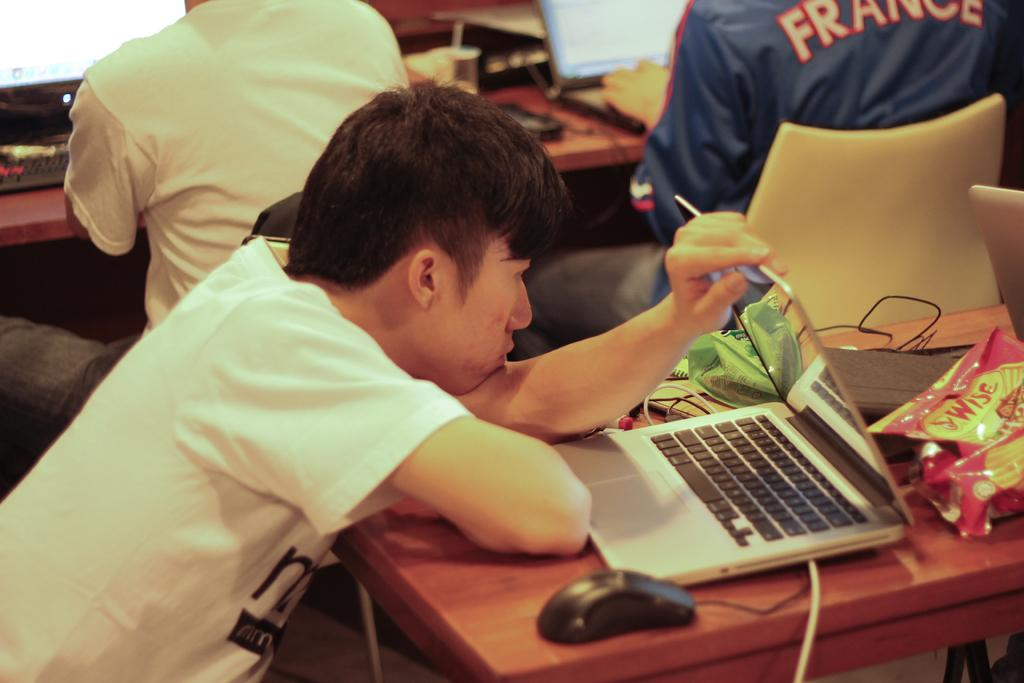How many people are in the image? There are three persons in the image. What are the persons doing in the image? The persons are sitting on chairs. How are the chairs arranged in the image? The chairs are arranged around a table. What objects can be seen on the table in the image? There is a laptop, a chips packet, and a mouse on the table. What type of club is being used by the persons in the image? There is no club present in the image; the persons are sitting on chairs and not using any clubs. What time does the watch in the image show? There is no watch present in the image. 